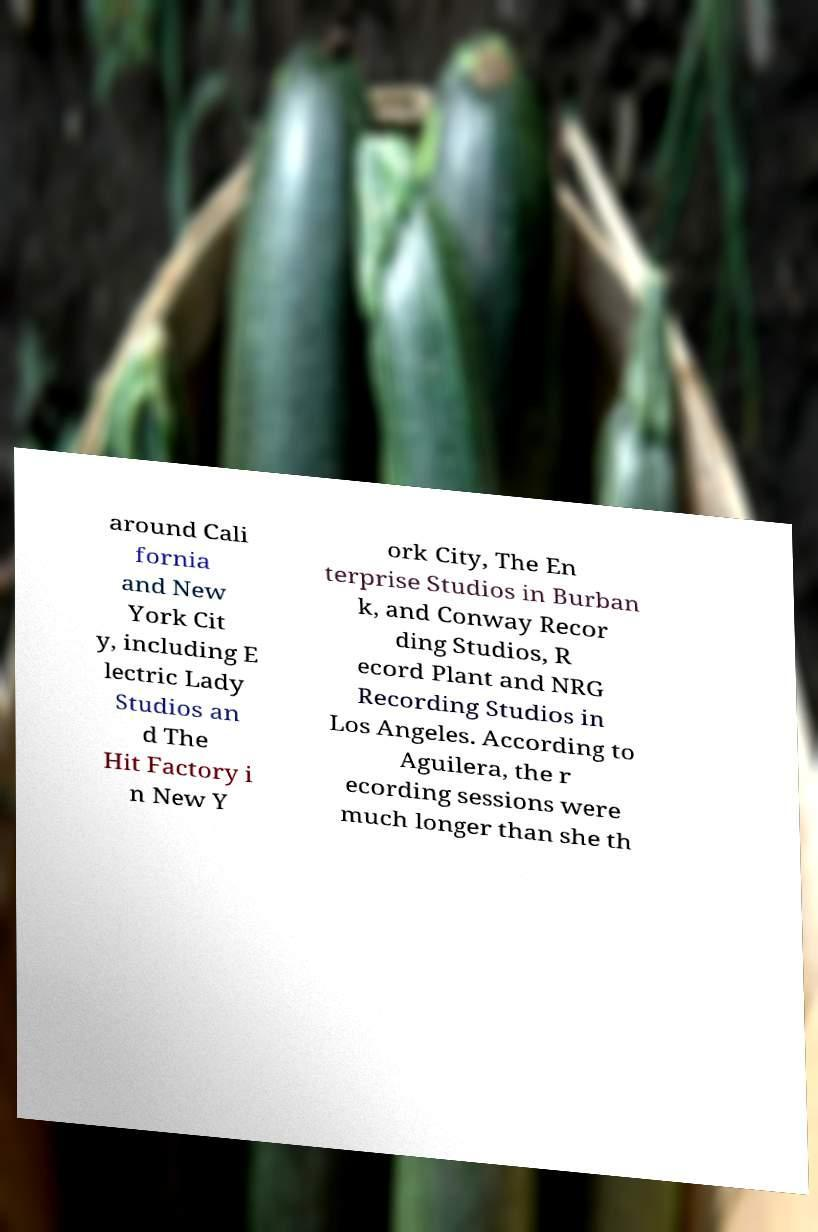Can you accurately transcribe the text from the provided image for me? around Cali fornia and New York Cit y, including E lectric Lady Studios an d The Hit Factory i n New Y ork City, The En terprise Studios in Burban k, and Conway Recor ding Studios, R ecord Plant and NRG Recording Studios in Los Angeles. According to Aguilera, the r ecording sessions were much longer than she th 